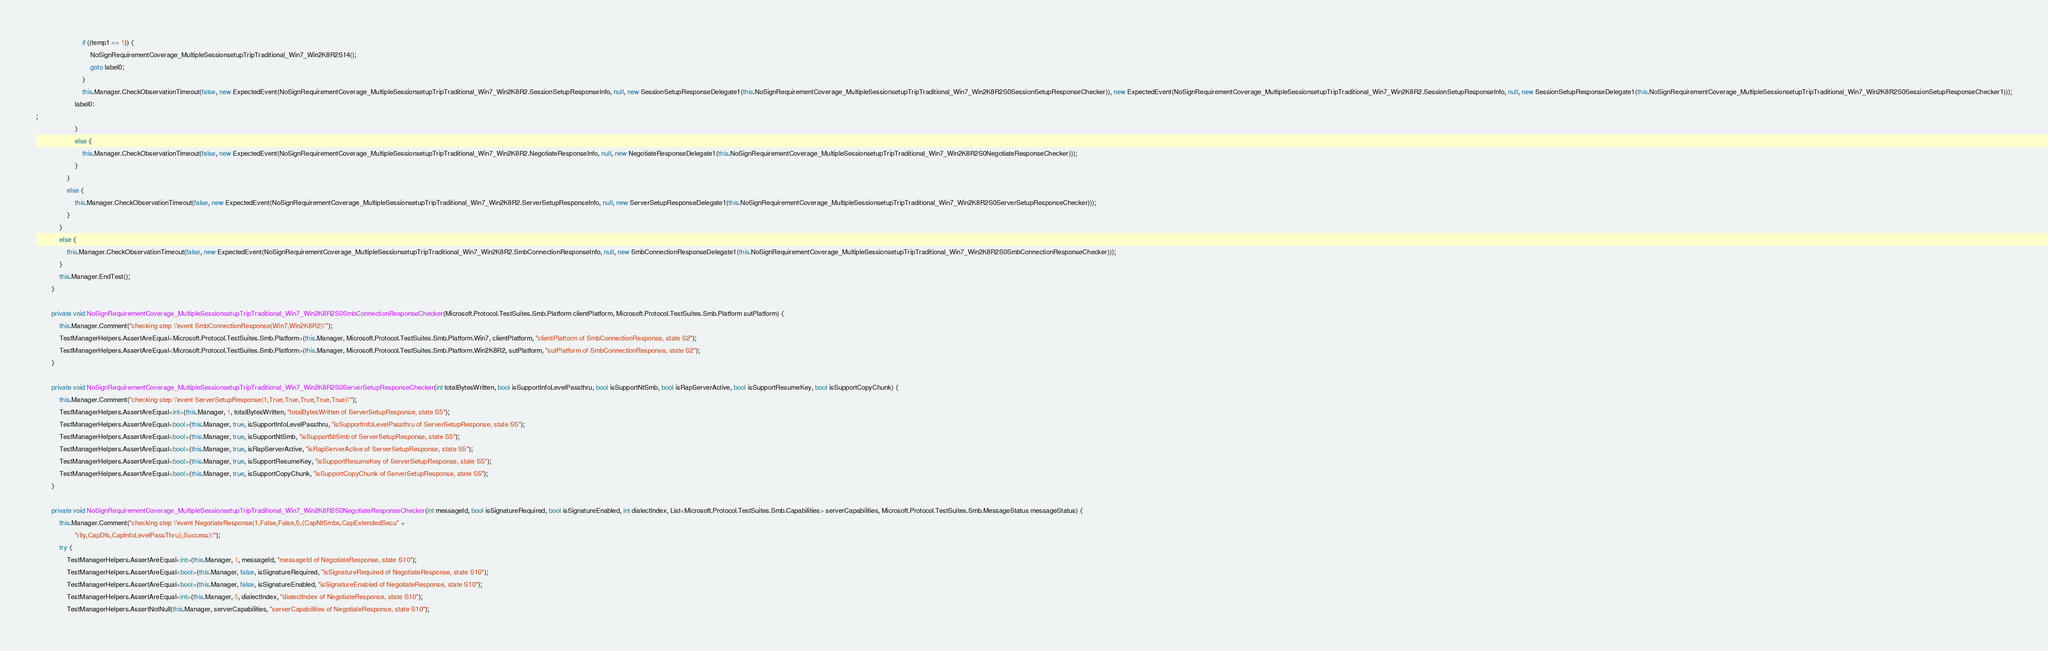<code> <loc_0><loc_0><loc_500><loc_500><_C#_>                        if ((temp1 == 1)) {
                            NoSignRequirementCoverage_MultipleSessionsetupTripTraditional_Win7_Win2K8R2S14();
                            goto label0;
                        }
                        this.Manager.CheckObservationTimeout(false, new ExpectedEvent(NoSignRequirementCoverage_MultipleSessionsetupTripTraditional_Win7_Win2K8R2.SessionSetupResponseInfo, null, new SessionSetupResponseDelegate1(this.NoSignRequirementCoverage_MultipleSessionsetupTripTraditional_Win7_Win2K8R2S0SessionSetupResponseChecker)), new ExpectedEvent(NoSignRequirementCoverage_MultipleSessionsetupTripTraditional_Win7_Win2K8R2.SessionSetupResponseInfo, null, new SessionSetupResponseDelegate1(this.NoSignRequirementCoverage_MultipleSessionsetupTripTraditional_Win7_Win2K8R2S0SessionSetupResponseChecker1)));
                    label0:
;
                    }
                    else {
                        this.Manager.CheckObservationTimeout(false, new ExpectedEvent(NoSignRequirementCoverage_MultipleSessionsetupTripTraditional_Win7_Win2K8R2.NegotiateResponseInfo, null, new NegotiateResponseDelegate1(this.NoSignRequirementCoverage_MultipleSessionsetupTripTraditional_Win7_Win2K8R2S0NegotiateResponseChecker)));
                    }
                }
                else {
                    this.Manager.CheckObservationTimeout(false, new ExpectedEvent(NoSignRequirementCoverage_MultipleSessionsetupTripTraditional_Win7_Win2K8R2.ServerSetupResponseInfo, null, new ServerSetupResponseDelegate1(this.NoSignRequirementCoverage_MultipleSessionsetupTripTraditional_Win7_Win2K8R2S0ServerSetupResponseChecker)));
                }
            }
            else {
                this.Manager.CheckObservationTimeout(false, new ExpectedEvent(NoSignRequirementCoverage_MultipleSessionsetupTripTraditional_Win7_Win2K8R2.SmbConnectionResponseInfo, null, new SmbConnectionResponseDelegate1(this.NoSignRequirementCoverage_MultipleSessionsetupTripTraditional_Win7_Win2K8R2S0SmbConnectionResponseChecker)));
            }
            this.Manager.EndTest();
        }
        
        private void NoSignRequirementCoverage_MultipleSessionsetupTripTraditional_Win7_Win2K8R2S0SmbConnectionResponseChecker(Microsoft.Protocol.TestSuites.Smb.Platform clientPlatform, Microsoft.Protocol.TestSuites.Smb.Platform sutPlatform) {
            this.Manager.Comment("checking step \'event SmbConnectionResponse(Win7,Win2K8R2)\'");
            TestManagerHelpers.AssertAreEqual<Microsoft.Protocol.TestSuites.Smb.Platform>(this.Manager, Microsoft.Protocol.TestSuites.Smb.Platform.Win7, clientPlatform, "clientPlatform of SmbConnectionResponse, state S2");
            TestManagerHelpers.AssertAreEqual<Microsoft.Protocol.TestSuites.Smb.Platform>(this.Manager, Microsoft.Protocol.TestSuites.Smb.Platform.Win2K8R2, sutPlatform, "sutPlatform of SmbConnectionResponse, state S2");
        }
        
        private void NoSignRequirementCoverage_MultipleSessionsetupTripTraditional_Win7_Win2K8R2S0ServerSetupResponseChecker(int totalBytesWritten, bool isSupportInfoLevelPassthru, bool isSupportNtSmb, bool isRapServerActive, bool isSupportResumeKey, bool isSupportCopyChunk) {
            this.Manager.Comment("checking step \'event ServerSetupResponse(1,True,True,True,True,True)\'");
            TestManagerHelpers.AssertAreEqual<int>(this.Manager, 1, totalBytesWritten, "totalBytesWritten of ServerSetupResponse, state S5");
            TestManagerHelpers.AssertAreEqual<bool>(this.Manager, true, isSupportInfoLevelPassthru, "isSupportInfoLevelPassthru of ServerSetupResponse, state S5");
            TestManagerHelpers.AssertAreEqual<bool>(this.Manager, true, isSupportNtSmb, "isSupportNtSmb of ServerSetupResponse, state S5");
            TestManagerHelpers.AssertAreEqual<bool>(this.Manager, true, isRapServerActive, "isRapServerActive of ServerSetupResponse, state S5");
            TestManagerHelpers.AssertAreEqual<bool>(this.Manager, true, isSupportResumeKey, "isSupportResumeKey of ServerSetupResponse, state S5");
            TestManagerHelpers.AssertAreEqual<bool>(this.Manager, true, isSupportCopyChunk, "isSupportCopyChunk of ServerSetupResponse, state S5");
        }
        
        private void NoSignRequirementCoverage_MultipleSessionsetupTripTraditional_Win7_Win2K8R2S0NegotiateResponseChecker(int messageId, bool isSignatureRequired, bool isSignatureEnabled, int dialectIndex, List<Microsoft.Protocol.TestSuites.Smb.Capabilities> serverCapabilities, Microsoft.Protocol.TestSuites.Smb.MessageStatus messageStatus) {
            this.Manager.Comment("checking step \'event NegotiateResponse(1,False,False,5,{CapNtSmbs,CapExtendedSecu" +
                    "rity,CapDfs,CapInfoLevelPassThru},Success)\'");
            try {
                TestManagerHelpers.AssertAreEqual<int>(this.Manager, 1, messageId, "messageId of NegotiateResponse, state S10");
                TestManagerHelpers.AssertAreEqual<bool>(this.Manager, false, isSignatureRequired, "isSignatureRequired of NegotiateResponse, state S10");
                TestManagerHelpers.AssertAreEqual<bool>(this.Manager, false, isSignatureEnabled, "isSignatureEnabled of NegotiateResponse, state S10");
                TestManagerHelpers.AssertAreEqual<int>(this.Manager, 5, dialectIndex, "dialectIndex of NegotiateResponse, state S10");
                TestManagerHelpers.AssertNotNull(this.Manager, serverCapabilities, "serverCapabilities of NegotiateResponse, state S10");</code> 